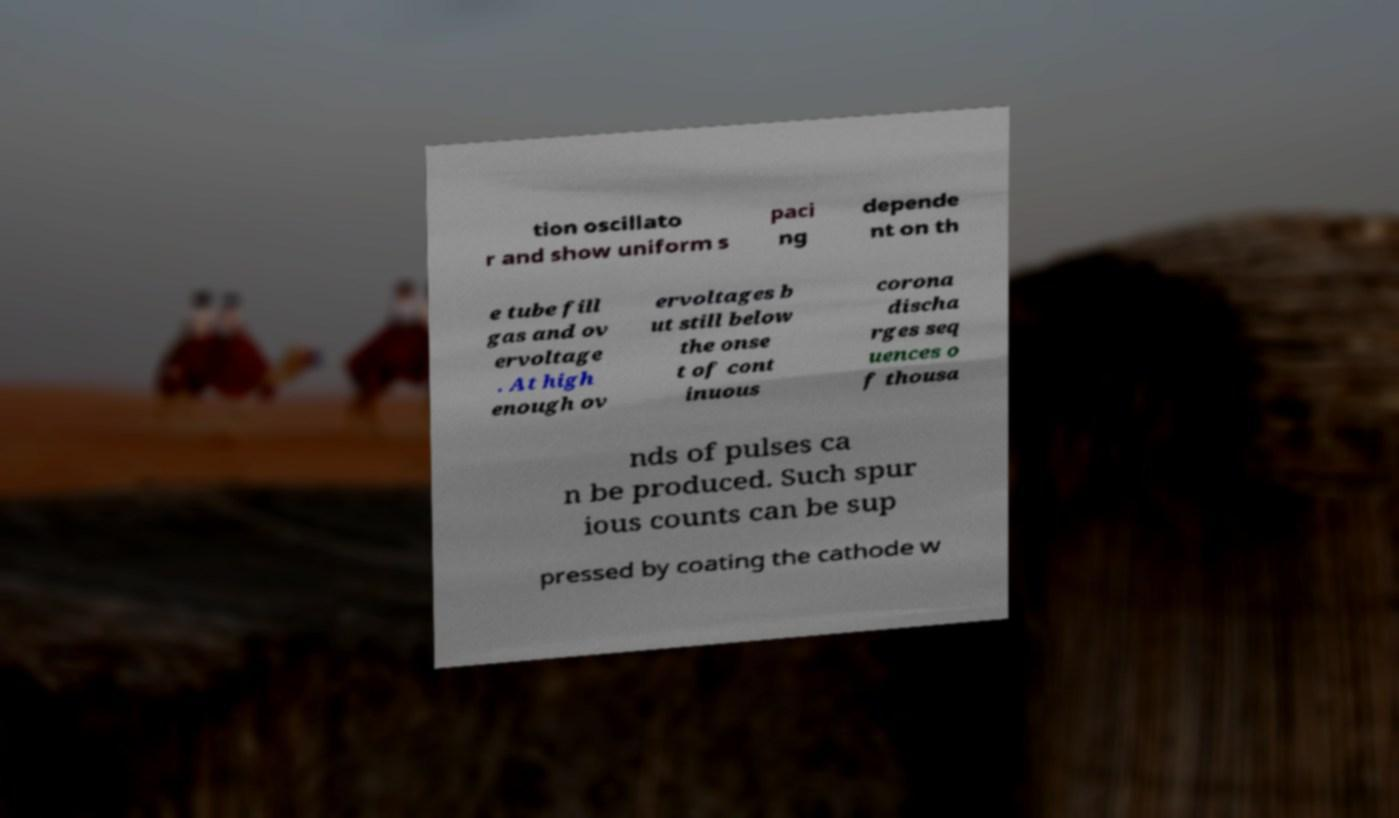There's text embedded in this image that I need extracted. Can you transcribe it verbatim? tion oscillato r and show uniform s paci ng depende nt on th e tube fill gas and ov ervoltage . At high enough ov ervoltages b ut still below the onse t of cont inuous corona discha rges seq uences o f thousa nds of pulses ca n be produced. Such spur ious counts can be sup pressed by coating the cathode w 